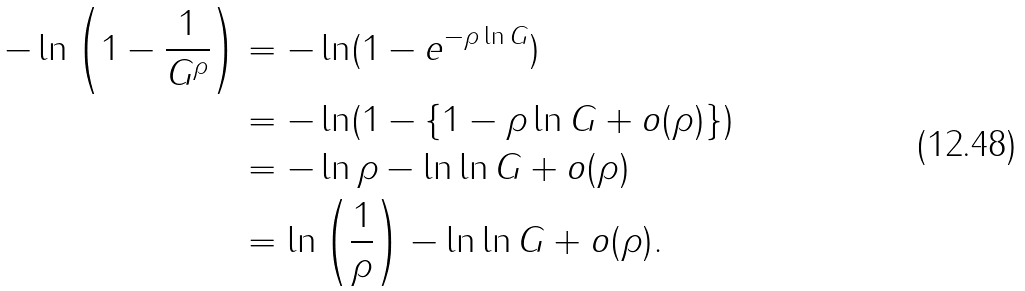Convert formula to latex. <formula><loc_0><loc_0><loc_500><loc_500>- \ln \left ( 1 - \frac { 1 } { G ^ { \rho } } \right ) & = - \ln ( 1 - e ^ { - \rho \ln G } ) \\ & = - \ln ( 1 - \{ 1 - \rho \ln G + o ( \rho ) \} ) \\ & = - \ln \rho - \ln \ln G + o ( \rho ) \\ & = \ln \left ( \frac { 1 } { \rho } \right ) - \ln \ln G + o ( \rho ) .</formula> 